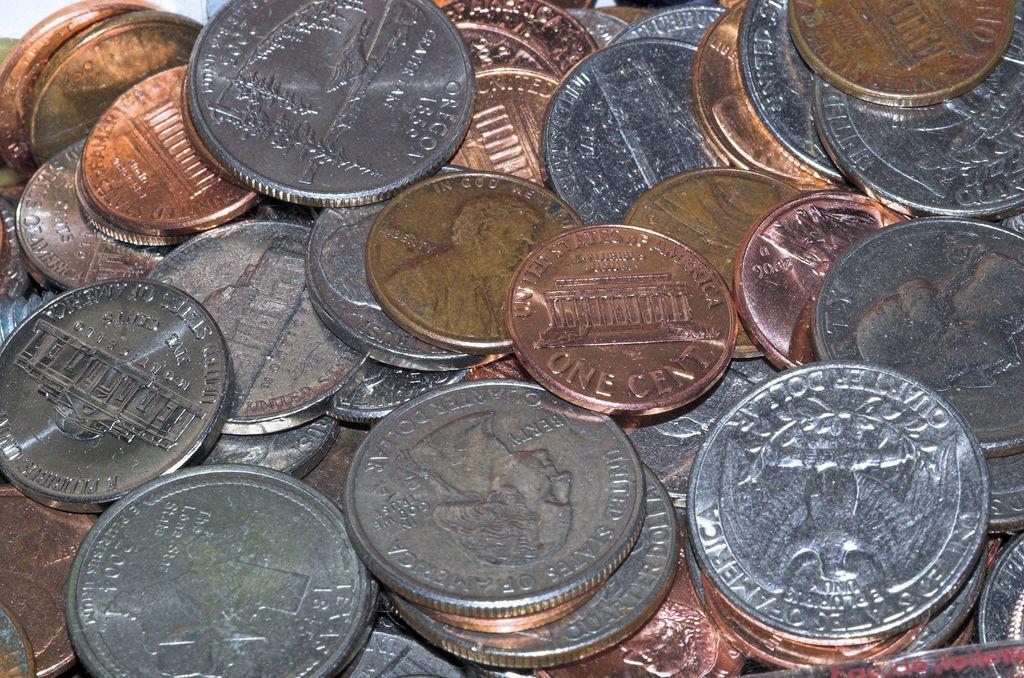Can you describe this image briefly? In this image we can see three different color coins. 